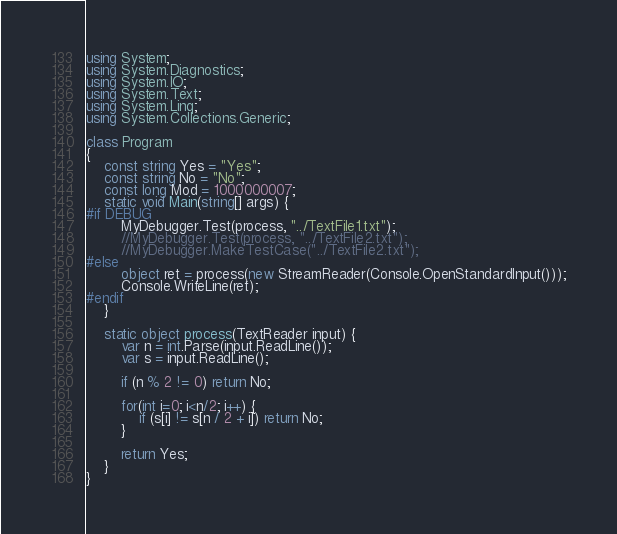Convert code to text. <code><loc_0><loc_0><loc_500><loc_500><_C#_>using System;
using System.Diagnostics;
using System.IO;
using System.Text;
using System.Linq;
using System.Collections.Generic;

class Program
{
    const string Yes = "Yes";
    const string No = "No";
    const long Mod = 1000000007;
    static void Main(string[] args) {
#if DEBUG
        MyDebugger.Test(process, "../TextFile1.txt");
        //MyDebugger.Test(process, "../TextFile2.txt");
        //MyDebugger.MakeTestCase("../TextFile2.txt");
#else
        object ret = process(new StreamReader(Console.OpenStandardInput()));
        Console.WriteLine(ret);
#endif
    }

    static object process(TextReader input) {
        var n = int.Parse(input.ReadLine());
        var s = input.ReadLine();

        if (n % 2 != 0) return No;

        for(int i=0; i<n/2; i++) {
            if (s[i] != s[n / 2 + i]) return No;
        }

        return Yes;
    }
}</code> 